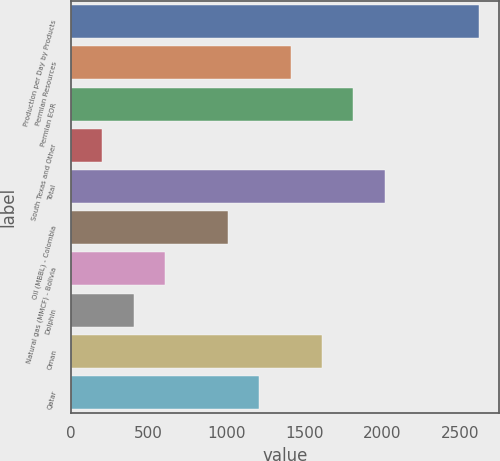Convert chart. <chart><loc_0><loc_0><loc_500><loc_500><bar_chart><fcel>Production per Day by Products<fcel>Permian Resources<fcel>Permian EOR<fcel>South Texas and Other<fcel>Total<fcel>Oil (MBBL) - Colombia<fcel>Natural gas (MMCF) - Bolivia<fcel>Dolphin<fcel>Oman<fcel>Qatar<nl><fcel>2620.2<fcel>1411.8<fcel>1814.6<fcel>203.4<fcel>2016<fcel>1009<fcel>606.2<fcel>404.8<fcel>1613.2<fcel>1210.4<nl></chart> 